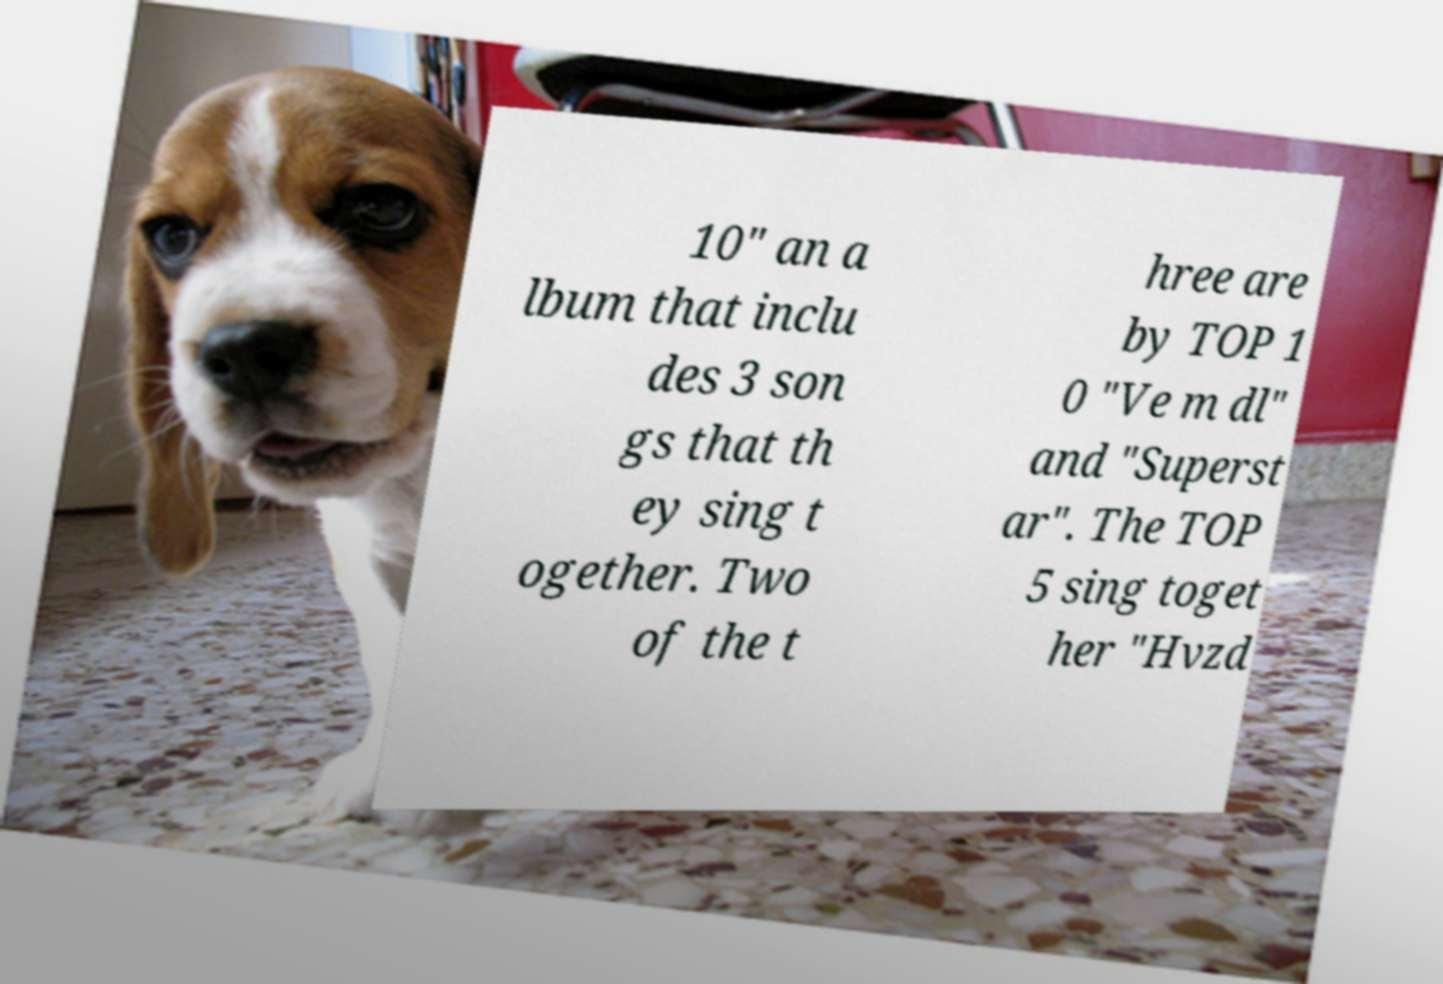Please read and relay the text visible in this image. What does it say? 10" an a lbum that inclu des 3 son gs that th ey sing t ogether. Two of the t hree are by TOP 1 0 "Ve m dl" and "Superst ar". The TOP 5 sing toget her "Hvzd 